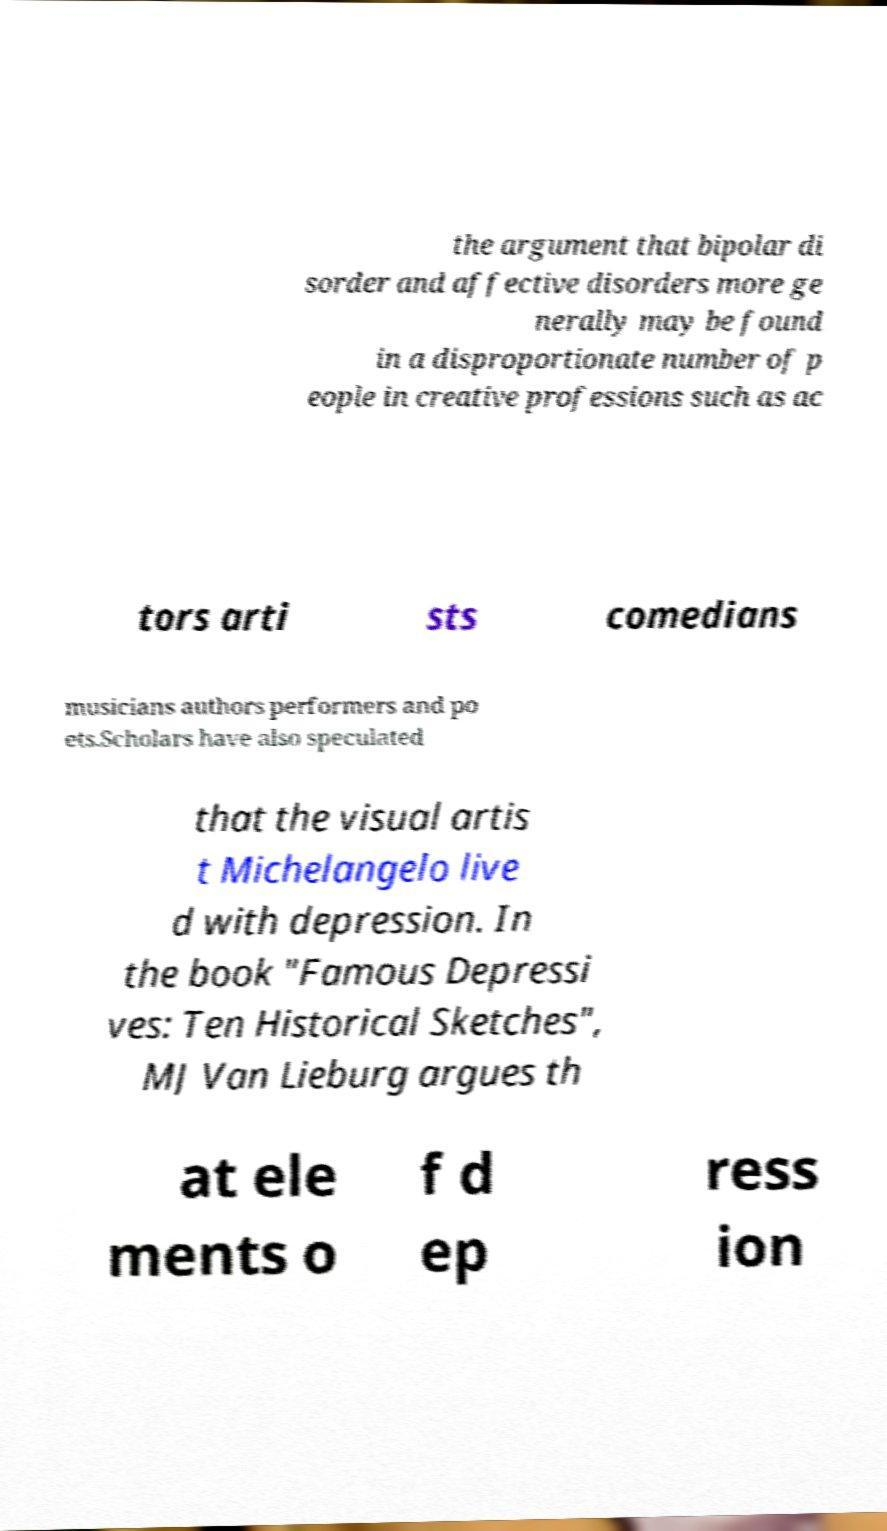What messages or text are displayed in this image? I need them in a readable, typed format. the argument that bipolar di sorder and affective disorders more ge nerally may be found in a disproportionate number of p eople in creative professions such as ac tors arti sts comedians musicians authors performers and po ets.Scholars have also speculated that the visual artis t Michelangelo live d with depression. In the book "Famous Depressi ves: Ten Historical Sketches", MJ Van Lieburg argues th at ele ments o f d ep ress ion 